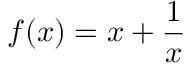<formula> <loc_0><loc_0><loc_500><loc_500>f ( x ) = x + { \frac { 1 } { x } }</formula> 